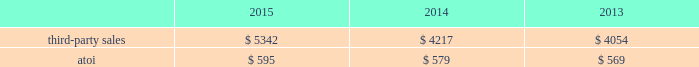Engineered products and solutions .
This segment represents a portion of alcoa 2019s downstream operations and produces products that are used mostly in the aerospace ( commercial and defense ) , commercial transportation , and power generation end markets .
Such products include fastening systems ( titanium , steel , and nickel alloys ) and seamless rolled rings ( mostly nickel alloys ) ; and investment castings ( nickel super alloys , titanium , and aluminum ) , including airfoils and forged jet engine components ( e.g. , jet engine disks ) , all of which are sold directly to customers and through distributors .
More than 70% ( 70 % ) of the third- party sales in this segment are from the aerospace end market .
A small part of this segment also produces various forging and extrusion metal products for the oil and gas , industrial products , automotive , and land and sea defense end markets .
Seasonal decreases in sales are generally experienced in the third quarter of the year due to the european summer slowdown across all end markets .
Generally , the sales and costs and expenses of this segment are transacted in the local currency of the respective operations , which are mostly the u.s .
Dollar and the euro .
In march 2015 , alcoa completed the acquisition of an aerospace castings company , tital , a privately held company with approximately 650 employees based in germany .
Tital produces aluminum and titanium investment casting products for the aerospace and defense end markets .
In 2014 , tital generated sales of approximately $ 100 .
The purpose of this acquisition is to capture increasing demand for advanced jet engine components made of titanium , establish titanium-casting capabilities in europe , and expand existing aluminum casting capacity .
The operating results and assets and liabilities of tital were included within the engineered products and solutions segment since the date of acquisition .
Also in march 2015 , alcoa signed a definitive agreement to acquire rti international metals , inc .
( rti ) , a global supplier of titanium and specialty metal products and services for the commercial aerospace , defense , energy , and medical device end markets .
On july 23 , 2015 , after satisfying all customary closing conditions and receiving the required regulatory and rti shareholder approvals , alcoa completed the acquisition of rti .
The purpose of this acquisition is to expand alcoa 2019s range of titanium offerings and add advanced technologies and materials , primarily related to the aerospace end market .
In 2014 , rti generated net sales of $ 794 and had approximately 2600 employees .
Alcoa estimates that rti will generate approximately $ 1200 in third-party sales by 2019 .
In executing its integration plan for rti , alcoa expects to realize annual cost savings of approximately $ 100 by 2019 due to synergies derived from procurement and productivity improvements , leveraging alcoa 2019s global shared services , and driving profitable growth .
The operating results and assets and liabilities of rti were included within the engineered products and solutions segment since the date of acquisition .
On november 19 , 2014 , after satisfying all customary closing conditions and receiving the required regulatory approvals , alcoa completed the acquisition of firth rixson , a global leader in aerospace jet engine components .
Firth rixson manufactures rings , forgings , and metal products for the aerospace end market , as well as other markets requiring highly engineered material applications .
The purpose of this acquisition is to strengthen alcoa 2019s aerospace business and position the company to capture additional aerospace growth with a broader range of high-growth , value- add jet engine components .
This business generated sales of approximately $ 970 in 2014 and has 13 operating facilities in the united states , united kingdom , europe , and asia employing approximately 2400 people combined .
In executing its integration plan for firth rixson , alcoa expects to realize annual cost savings of more than $ 100 by 2019 due to synergies derived from procurement and productivity improvements , optimizing internal metal supply , and leveraging alcoa 2019s global shared services .
The operating results and assets and liabilities of firth rixson were included within the engineered products and solutions segment since the date of acquisition .
Third-party sales for the engineered products and solutions segment improved 27% ( 27 % ) in 2015 compared with 2014 , largely attributable to the third-party sales ( $ 1310 ) of three acquired businesses ( see above ) , primarily aerospace- related , and higher volumes in this segment 2019s organic businesses , mostly related to the aerospace end market .
These positive impacts were slightly offset by unfavorable foreign currency movements , principally driven by a weaker euro. .
What is the percentage of the three acquired businesses , that were responsible for the 27% ( 27 % ) improvement in third-party sales? 
Rationale: it is the total sales of these three aquired businesses divided by the total of the third-party sales.\\n
Computations: (1310 / 5342)
Answer: 0.24523. 